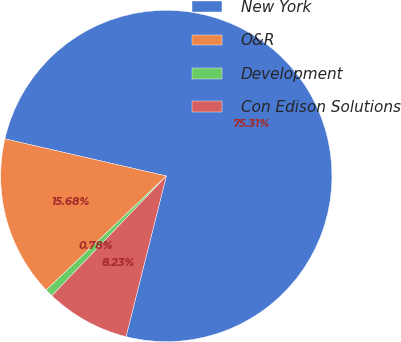Convert chart to OTSL. <chart><loc_0><loc_0><loc_500><loc_500><pie_chart><fcel>New York<fcel>O&R<fcel>Development<fcel>Con Edison Solutions<nl><fcel>75.31%<fcel>15.68%<fcel>0.78%<fcel>8.23%<nl></chart> 